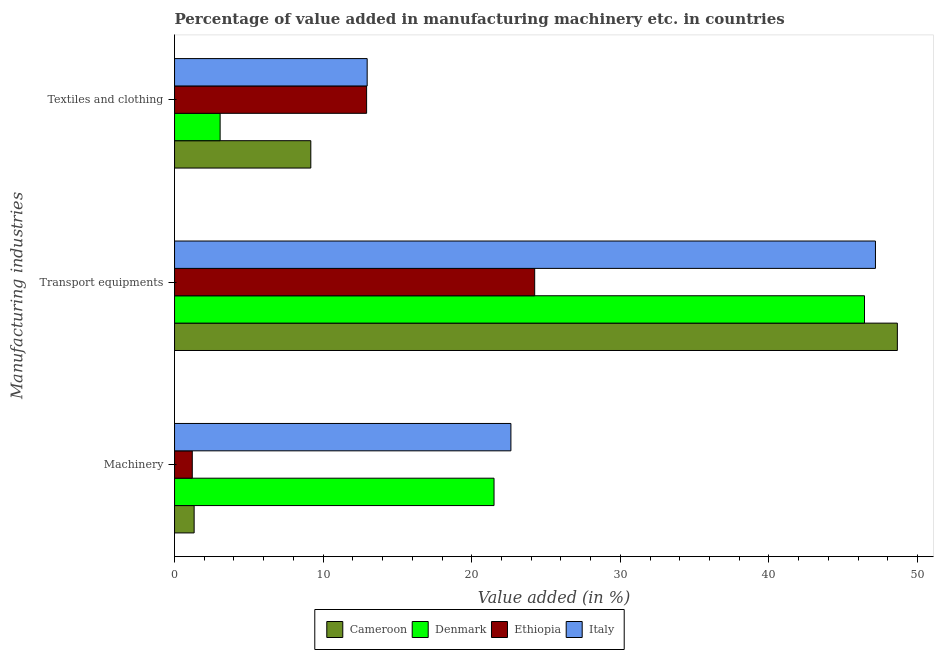How many different coloured bars are there?
Keep it short and to the point. 4. How many groups of bars are there?
Your response must be concise. 3. Are the number of bars on each tick of the Y-axis equal?
Your answer should be very brief. Yes. What is the label of the 2nd group of bars from the top?
Ensure brevity in your answer.  Transport equipments. What is the value added in manufacturing textile and clothing in Ethiopia?
Give a very brief answer. 12.93. Across all countries, what is the maximum value added in manufacturing machinery?
Offer a terse response. 22.64. Across all countries, what is the minimum value added in manufacturing transport equipments?
Provide a succinct answer. 24.24. In which country was the value added in manufacturing transport equipments maximum?
Give a very brief answer. Cameroon. In which country was the value added in manufacturing machinery minimum?
Your response must be concise. Ethiopia. What is the total value added in manufacturing textile and clothing in the graph?
Offer a terse response. 38.13. What is the difference between the value added in manufacturing transport equipments in Cameroon and that in Italy?
Keep it short and to the point. 1.47. What is the difference between the value added in manufacturing textile and clothing in Ethiopia and the value added in manufacturing transport equipments in Italy?
Ensure brevity in your answer.  -34.25. What is the average value added in manufacturing machinery per country?
Ensure brevity in your answer.  11.66. What is the difference between the value added in manufacturing transport equipments and value added in manufacturing textile and clothing in Denmark?
Give a very brief answer. 43.37. In how many countries, is the value added in manufacturing transport equipments greater than 20 %?
Keep it short and to the point. 4. What is the ratio of the value added in manufacturing textile and clothing in Italy to that in Cameroon?
Keep it short and to the point. 1.41. What is the difference between the highest and the second highest value added in manufacturing machinery?
Your answer should be very brief. 1.14. What is the difference between the highest and the lowest value added in manufacturing textile and clothing?
Your response must be concise. 9.9. In how many countries, is the value added in manufacturing machinery greater than the average value added in manufacturing machinery taken over all countries?
Keep it short and to the point. 2. Is the sum of the value added in manufacturing transport equipments in Italy and Cameroon greater than the maximum value added in manufacturing textile and clothing across all countries?
Provide a succinct answer. Yes. What does the 4th bar from the top in Machinery represents?
Your response must be concise. Cameroon. Is it the case that in every country, the sum of the value added in manufacturing machinery and value added in manufacturing transport equipments is greater than the value added in manufacturing textile and clothing?
Ensure brevity in your answer.  Yes. How many bars are there?
Ensure brevity in your answer.  12. Are all the bars in the graph horizontal?
Provide a short and direct response. Yes. How many countries are there in the graph?
Offer a very short reply. 4. Does the graph contain any zero values?
Keep it short and to the point. No. Does the graph contain grids?
Keep it short and to the point. No. How are the legend labels stacked?
Your answer should be compact. Horizontal. What is the title of the graph?
Provide a short and direct response. Percentage of value added in manufacturing machinery etc. in countries. Does "Mongolia" appear as one of the legend labels in the graph?
Make the answer very short. No. What is the label or title of the X-axis?
Offer a very short reply. Value added (in %). What is the label or title of the Y-axis?
Give a very brief answer. Manufacturing industries. What is the Value added (in %) in Cameroon in Machinery?
Offer a terse response. 1.32. What is the Value added (in %) in Denmark in Machinery?
Provide a succinct answer. 21.5. What is the Value added (in %) in Ethiopia in Machinery?
Provide a short and direct response. 1.19. What is the Value added (in %) in Italy in Machinery?
Provide a succinct answer. 22.64. What is the Value added (in %) in Cameroon in Transport equipments?
Your response must be concise. 48.65. What is the Value added (in %) in Denmark in Transport equipments?
Provide a short and direct response. 46.44. What is the Value added (in %) of Ethiopia in Transport equipments?
Offer a terse response. 24.24. What is the Value added (in %) of Italy in Transport equipments?
Ensure brevity in your answer.  47.17. What is the Value added (in %) of Cameroon in Textiles and clothing?
Provide a succinct answer. 9.17. What is the Value added (in %) of Denmark in Textiles and clothing?
Give a very brief answer. 3.07. What is the Value added (in %) in Ethiopia in Textiles and clothing?
Your answer should be compact. 12.93. What is the Value added (in %) of Italy in Textiles and clothing?
Give a very brief answer. 12.96. Across all Manufacturing industries, what is the maximum Value added (in %) of Cameroon?
Provide a short and direct response. 48.65. Across all Manufacturing industries, what is the maximum Value added (in %) of Denmark?
Your answer should be very brief. 46.44. Across all Manufacturing industries, what is the maximum Value added (in %) of Ethiopia?
Provide a short and direct response. 24.24. Across all Manufacturing industries, what is the maximum Value added (in %) in Italy?
Give a very brief answer. 47.17. Across all Manufacturing industries, what is the minimum Value added (in %) in Cameroon?
Your answer should be compact. 1.32. Across all Manufacturing industries, what is the minimum Value added (in %) of Denmark?
Your response must be concise. 3.07. Across all Manufacturing industries, what is the minimum Value added (in %) in Ethiopia?
Your answer should be very brief. 1.19. Across all Manufacturing industries, what is the minimum Value added (in %) in Italy?
Keep it short and to the point. 12.96. What is the total Value added (in %) in Cameroon in the graph?
Your answer should be compact. 59.13. What is the total Value added (in %) in Denmark in the graph?
Ensure brevity in your answer.  71. What is the total Value added (in %) in Ethiopia in the graph?
Make the answer very short. 38.36. What is the total Value added (in %) of Italy in the graph?
Provide a succinct answer. 82.77. What is the difference between the Value added (in %) in Cameroon in Machinery and that in Transport equipments?
Your response must be concise. -47.33. What is the difference between the Value added (in %) in Denmark in Machinery and that in Transport equipments?
Offer a terse response. -24.93. What is the difference between the Value added (in %) of Ethiopia in Machinery and that in Transport equipments?
Offer a terse response. -23.04. What is the difference between the Value added (in %) in Italy in Machinery and that in Transport equipments?
Keep it short and to the point. -24.53. What is the difference between the Value added (in %) of Cameroon in Machinery and that in Textiles and clothing?
Your answer should be very brief. -7.85. What is the difference between the Value added (in %) of Denmark in Machinery and that in Textiles and clothing?
Give a very brief answer. 18.43. What is the difference between the Value added (in %) of Ethiopia in Machinery and that in Textiles and clothing?
Provide a short and direct response. -11.73. What is the difference between the Value added (in %) of Italy in Machinery and that in Textiles and clothing?
Keep it short and to the point. 9.67. What is the difference between the Value added (in %) in Cameroon in Transport equipments and that in Textiles and clothing?
Your answer should be very brief. 39.48. What is the difference between the Value added (in %) of Denmark in Transport equipments and that in Textiles and clothing?
Your answer should be very brief. 43.37. What is the difference between the Value added (in %) of Ethiopia in Transport equipments and that in Textiles and clothing?
Give a very brief answer. 11.31. What is the difference between the Value added (in %) in Italy in Transport equipments and that in Textiles and clothing?
Your answer should be compact. 34.21. What is the difference between the Value added (in %) in Cameroon in Machinery and the Value added (in %) in Denmark in Transport equipments?
Make the answer very short. -45.12. What is the difference between the Value added (in %) in Cameroon in Machinery and the Value added (in %) in Ethiopia in Transport equipments?
Offer a very short reply. -22.92. What is the difference between the Value added (in %) in Cameroon in Machinery and the Value added (in %) in Italy in Transport equipments?
Your answer should be very brief. -45.85. What is the difference between the Value added (in %) in Denmark in Machinery and the Value added (in %) in Ethiopia in Transport equipments?
Keep it short and to the point. -2.74. What is the difference between the Value added (in %) in Denmark in Machinery and the Value added (in %) in Italy in Transport equipments?
Your answer should be compact. -25.67. What is the difference between the Value added (in %) in Ethiopia in Machinery and the Value added (in %) in Italy in Transport equipments?
Provide a succinct answer. -45.98. What is the difference between the Value added (in %) of Cameroon in Machinery and the Value added (in %) of Denmark in Textiles and clothing?
Your answer should be compact. -1.75. What is the difference between the Value added (in %) in Cameroon in Machinery and the Value added (in %) in Ethiopia in Textiles and clothing?
Provide a succinct answer. -11.61. What is the difference between the Value added (in %) of Cameroon in Machinery and the Value added (in %) of Italy in Textiles and clothing?
Make the answer very short. -11.65. What is the difference between the Value added (in %) of Denmark in Machinery and the Value added (in %) of Ethiopia in Textiles and clothing?
Make the answer very short. 8.58. What is the difference between the Value added (in %) of Denmark in Machinery and the Value added (in %) of Italy in Textiles and clothing?
Ensure brevity in your answer.  8.54. What is the difference between the Value added (in %) in Ethiopia in Machinery and the Value added (in %) in Italy in Textiles and clothing?
Your answer should be very brief. -11.77. What is the difference between the Value added (in %) of Cameroon in Transport equipments and the Value added (in %) of Denmark in Textiles and clothing?
Make the answer very short. 45.58. What is the difference between the Value added (in %) of Cameroon in Transport equipments and the Value added (in %) of Ethiopia in Textiles and clothing?
Provide a short and direct response. 35.72. What is the difference between the Value added (in %) in Cameroon in Transport equipments and the Value added (in %) in Italy in Textiles and clothing?
Your answer should be compact. 35.68. What is the difference between the Value added (in %) of Denmark in Transport equipments and the Value added (in %) of Ethiopia in Textiles and clothing?
Offer a very short reply. 33.51. What is the difference between the Value added (in %) in Denmark in Transport equipments and the Value added (in %) in Italy in Textiles and clothing?
Offer a very short reply. 33.47. What is the difference between the Value added (in %) in Ethiopia in Transport equipments and the Value added (in %) in Italy in Textiles and clothing?
Offer a terse response. 11.27. What is the average Value added (in %) in Cameroon per Manufacturing industries?
Offer a very short reply. 19.71. What is the average Value added (in %) of Denmark per Manufacturing industries?
Your response must be concise. 23.67. What is the average Value added (in %) in Ethiopia per Manufacturing industries?
Your answer should be compact. 12.79. What is the average Value added (in %) in Italy per Manufacturing industries?
Offer a terse response. 27.59. What is the difference between the Value added (in %) in Cameroon and Value added (in %) in Denmark in Machinery?
Offer a very short reply. -20.18. What is the difference between the Value added (in %) of Cameroon and Value added (in %) of Ethiopia in Machinery?
Make the answer very short. 0.12. What is the difference between the Value added (in %) in Cameroon and Value added (in %) in Italy in Machinery?
Ensure brevity in your answer.  -21.32. What is the difference between the Value added (in %) in Denmark and Value added (in %) in Ethiopia in Machinery?
Keep it short and to the point. 20.31. What is the difference between the Value added (in %) in Denmark and Value added (in %) in Italy in Machinery?
Keep it short and to the point. -1.14. What is the difference between the Value added (in %) in Ethiopia and Value added (in %) in Italy in Machinery?
Ensure brevity in your answer.  -21.44. What is the difference between the Value added (in %) in Cameroon and Value added (in %) in Denmark in Transport equipments?
Provide a succinct answer. 2.21. What is the difference between the Value added (in %) of Cameroon and Value added (in %) of Ethiopia in Transport equipments?
Provide a short and direct response. 24.41. What is the difference between the Value added (in %) of Cameroon and Value added (in %) of Italy in Transport equipments?
Make the answer very short. 1.47. What is the difference between the Value added (in %) of Denmark and Value added (in %) of Ethiopia in Transport equipments?
Provide a succinct answer. 22.2. What is the difference between the Value added (in %) in Denmark and Value added (in %) in Italy in Transport equipments?
Offer a terse response. -0.74. What is the difference between the Value added (in %) in Ethiopia and Value added (in %) in Italy in Transport equipments?
Ensure brevity in your answer.  -22.93. What is the difference between the Value added (in %) in Cameroon and Value added (in %) in Denmark in Textiles and clothing?
Provide a succinct answer. 6.1. What is the difference between the Value added (in %) of Cameroon and Value added (in %) of Ethiopia in Textiles and clothing?
Your response must be concise. -3.76. What is the difference between the Value added (in %) of Cameroon and Value added (in %) of Italy in Textiles and clothing?
Your answer should be compact. -3.79. What is the difference between the Value added (in %) in Denmark and Value added (in %) in Ethiopia in Textiles and clothing?
Make the answer very short. -9.86. What is the difference between the Value added (in %) of Denmark and Value added (in %) of Italy in Textiles and clothing?
Ensure brevity in your answer.  -9.9. What is the difference between the Value added (in %) of Ethiopia and Value added (in %) of Italy in Textiles and clothing?
Provide a short and direct response. -0.04. What is the ratio of the Value added (in %) in Cameroon in Machinery to that in Transport equipments?
Ensure brevity in your answer.  0.03. What is the ratio of the Value added (in %) of Denmark in Machinery to that in Transport equipments?
Provide a succinct answer. 0.46. What is the ratio of the Value added (in %) in Ethiopia in Machinery to that in Transport equipments?
Offer a very short reply. 0.05. What is the ratio of the Value added (in %) of Italy in Machinery to that in Transport equipments?
Keep it short and to the point. 0.48. What is the ratio of the Value added (in %) of Cameroon in Machinery to that in Textiles and clothing?
Keep it short and to the point. 0.14. What is the ratio of the Value added (in %) in Denmark in Machinery to that in Textiles and clothing?
Make the answer very short. 7.01. What is the ratio of the Value added (in %) of Ethiopia in Machinery to that in Textiles and clothing?
Provide a short and direct response. 0.09. What is the ratio of the Value added (in %) of Italy in Machinery to that in Textiles and clothing?
Ensure brevity in your answer.  1.75. What is the ratio of the Value added (in %) of Cameroon in Transport equipments to that in Textiles and clothing?
Your answer should be compact. 5.3. What is the ratio of the Value added (in %) in Denmark in Transport equipments to that in Textiles and clothing?
Your response must be concise. 15.14. What is the ratio of the Value added (in %) in Ethiopia in Transport equipments to that in Textiles and clothing?
Provide a succinct answer. 1.88. What is the ratio of the Value added (in %) in Italy in Transport equipments to that in Textiles and clothing?
Your answer should be very brief. 3.64. What is the difference between the highest and the second highest Value added (in %) of Cameroon?
Offer a terse response. 39.48. What is the difference between the highest and the second highest Value added (in %) in Denmark?
Your answer should be very brief. 24.93. What is the difference between the highest and the second highest Value added (in %) of Ethiopia?
Make the answer very short. 11.31. What is the difference between the highest and the second highest Value added (in %) of Italy?
Provide a short and direct response. 24.53. What is the difference between the highest and the lowest Value added (in %) in Cameroon?
Offer a terse response. 47.33. What is the difference between the highest and the lowest Value added (in %) of Denmark?
Your answer should be compact. 43.37. What is the difference between the highest and the lowest Value added (in %) in Ethiopia?
Make the answer very short. 23.04. What is the difference between the highest and the lowest Value added (in %) of Italy?
Give a very brief answer. 34.21. 